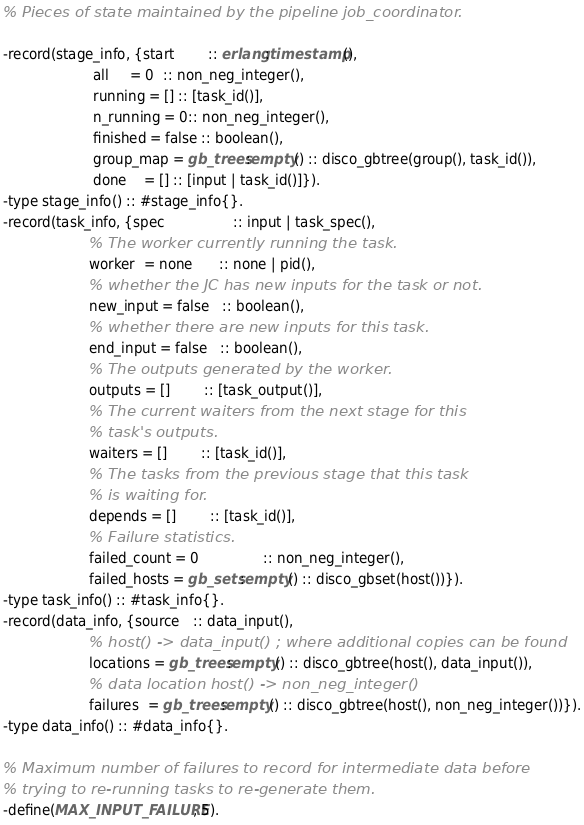Convert code to text. <code><loc_0><loc_0><loc_500><loc_500><_Erlang_>% Pieces of state maintained by the pipeline job_coordinator.

-record(stage_info, {start        :: erlang:timestamp(),
                     all     = 0  :: non_neg_integer(),
                     running = [] :: [task_id()],
                     n_running = 0:: non_neg_integer(),
                     finished = false :: boolean(),
                     group_map = gb_trees:empty() :: disco_gbtree(group(), task_id()),
                     done    = [] :: [input | task_id()]}).
-type stage_info() :: #stage_info{}.
-record(task_info, {spec                :: input | task_spec(),
                    % The worker currently running the task.
                    worker  = none      :: none | pid(),
                    % whether the JC has new inputs for the task or not.
                    new_input = false   :: boolean(),
                    % whether there are new inputs for this task.
                    end_input = false   :: boolean(),
                    % The outputs generated by the worker.
                    outputs = []        :: [task_output()],
                    % The current waiters from the next stage for this
                    % task's outputs.
                    waiters = []        :: [task_id()],
                    % The tasks from the previous stage that this task
                    % is waiting for.
                    depends = []        :: [task_id()],
                    % Failure statistics.
                    failed_count = 0               :: non_neg_integer(),
                    failed_hosts = gb_sets:empty() :: disco_gbset(host())}).
-type task_info() :: #task_info{}.
-record(data_info, {source   :: data_input(),
                    % host() -> data_input() ; where additional copies can be found
                    locations = gb_trees:empty() :: disco_gbtree(host(), data_input()),
                    % data location host() -> non_neg_integer()
                    failures  = gb_trees:empty() :: disco_gbtree(host(), non_neg_integer())}).
-type data_info() :: #data_info{}.

% Maximum number of failures to record for intermediate data before
% trying to re-running tasks to re-generate them.
-define(MAX_INPUT_FAILURE, 5).
</code> 